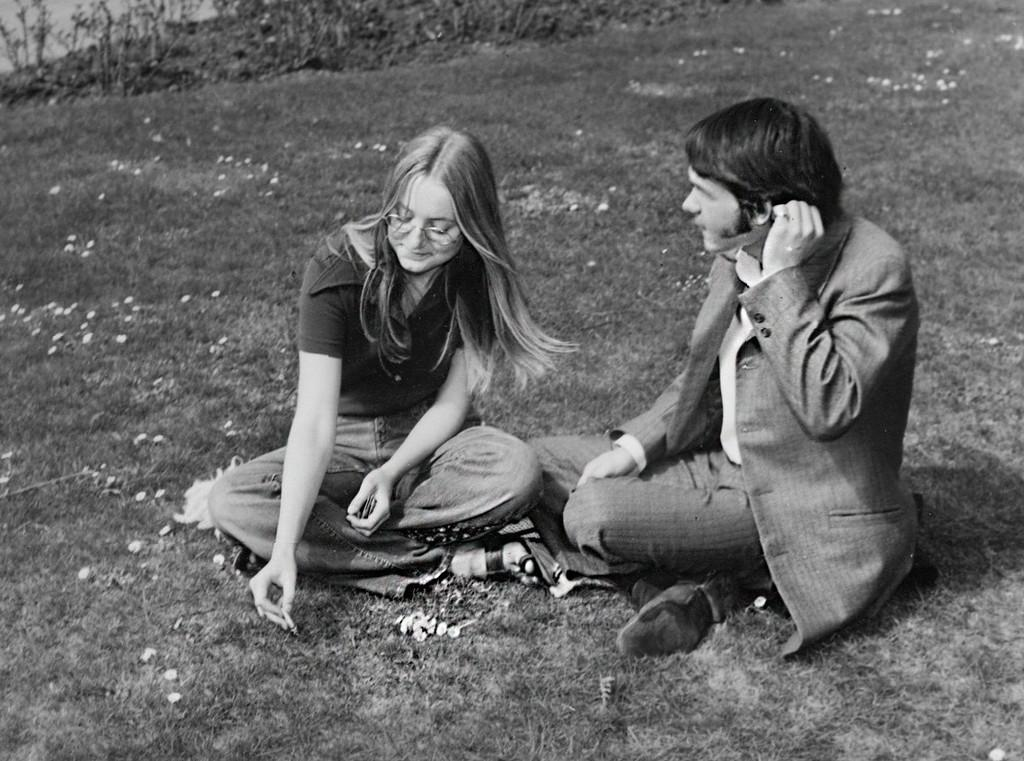How many people are in the image? There are two people in the image, a man and a woman. What are the man and woman doing in the image? The man and woman are sitting. Can you describe the woman's appearance in the image? The woman is wearing spectacles. What type of natural environment is visible in the image? There is grass, plants, and tiny flowers visible in the image. How many kittens are playing with the tomatoes in the image? There are no kittens or tomatoes present in the image. 